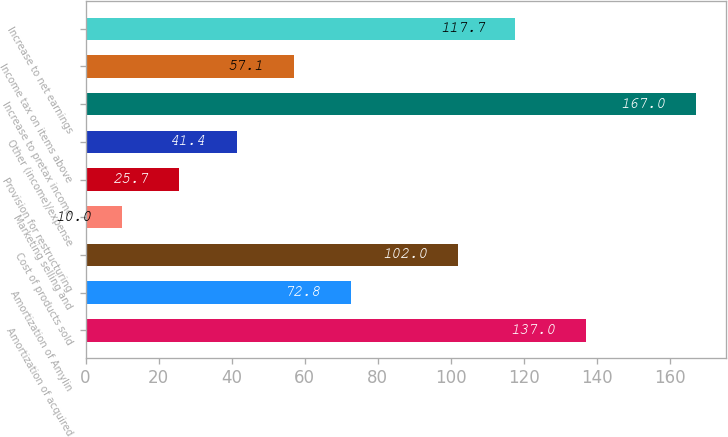Convert chart to OTSL. <chart><loc_0><loc_0><loc_500><loc_500><bar_chart><fcel>Amortization of acquired<fcel>Amortization of Amylin<fcel>Cost of products sold<fcel>Marketing selling and<fcel>Provision for restructuring<fcel>Other (income)/expense<fcel>Increase to pretax income<fcel>Income tax on items above<fcel>Increase to net earnings<nl><fcel>137<fcel>72.8<fcel>102<fcel>10<fcel>25.7<fcel>41.4<fcel>167<fcel>57.1<fcel>117.7<nl></chart> 